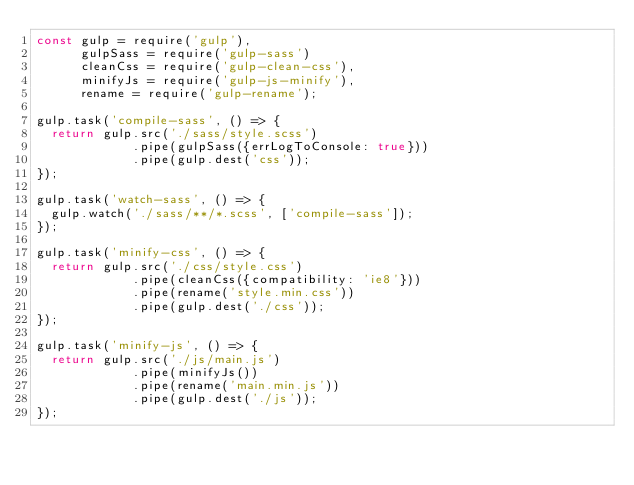<code> <loc_0><loc_0><loc_500><loc_500><_JavaScript_>const gulp = require('gulp'),
      gulpSass = require('gulp-sass')
      cleanCss = require('gulp-clean-css'),
      minifyJs = require('gulp-js-minify'),
      rename = require('gulp-rename');

gulp.task('compile-sass', () => {
  return gulp.src('./sass/style.scss')
             .pipe(gulpSass({errLogToConsole: true}))
             .pipe(gulp.dest('css'));
});

gulp.task('watch-sass', () => {
  gulp.watch('./sass/**/*.scss', ['compile-sass']);
});

gulp.task('minify-css', () => {
  return gulp.src('./css/style.css')
             .pipe(cleanCss({compatibility: 'ie8'}))
             .pipe(rename('style.min.css'))
             .pipe(gulp.dest('./css'));
});

gulp.task('minify-js', () => {
  return gulp.src('./js/main.js')
             .pipe(minifyJs())
             .pipe(rename('main.min.js'))
             .pipe(gulp.dest('./js'));
});
</code> 